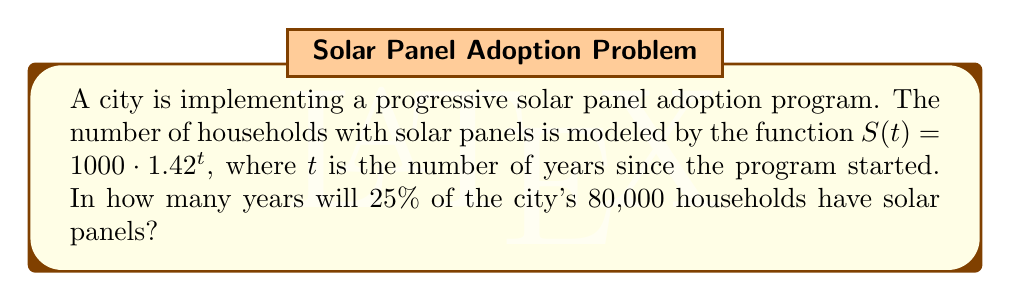Teach me how to tackle this problem. Let's approach this step-by-step:

1) We need to find when $S(t)$ equals 25% of 80,000:
   
   $25\% \text{ of } 80,000 = 0.25 \cdot 80,000 = 20,000$

2) So, we need to solve the equation:
   
   $1000 \cdot 1.42^t = 20,000$

3) Divide both sides by 1000:
   
   $1.42^t = 20$

4) Take the natural log of both sides:
   
   $\ln(1.42^t) = \ln(20)$

5) Using the logarithm property $\ln(a^b) = b\ln(a)$:
   
   $t \cdot \ln(1.42) = \ln(20)$

6) Solve for $t$:
   
   $t = \frac{\ln(20)}{\ln(1.42)} \approx 8.21$

7) Since we can't have a fractional year, we round up to the next whole year.
Answer: 9 years 